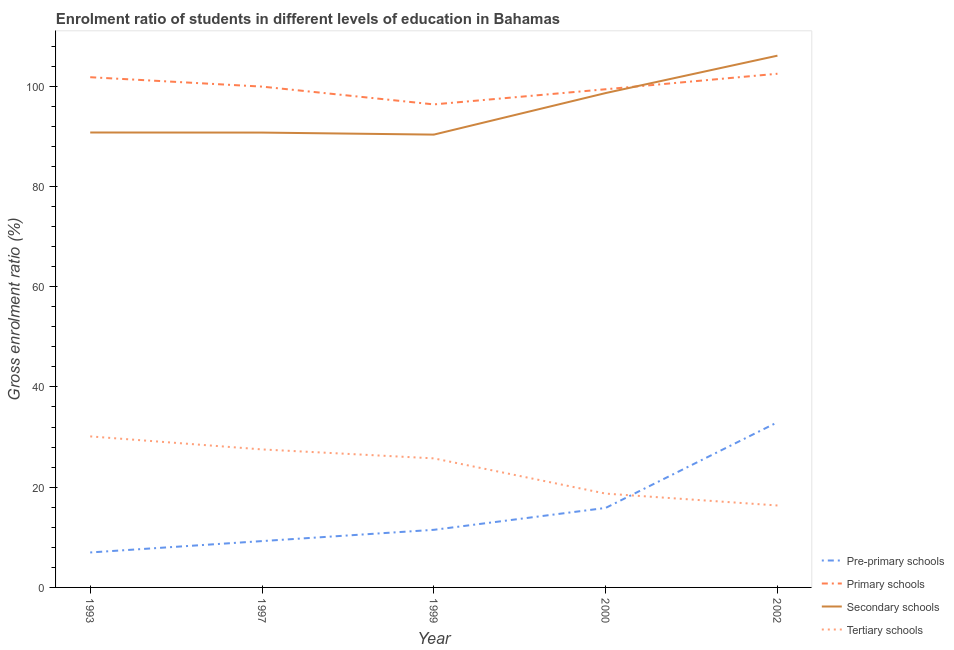How many different coloured lines are there?
Your answer should be compact. 4. Is the number of lines equal to the number of legend labels?
Offer a terse response. Yes. What is the gross enrolment ratio in secondary schools in 1999?
Your response must be concise. 90.34. Across all years, what is the maximum gross enrolment ratio in secondary schools?
Your answer should be compact. 106.09. Across all years, what is the minimum gross enrolment ratio in secondary schools?
Give a very brief answer. 90.34. In which year was the gross enrolment ratio in secondary schools minimum?
Give a very brief answer. 1999. What is the total gross enrolment ratio in secondary schools in the graph?
Offer a terse response. 476.59. What is the difference between the gross enrolment ratio in primary schools in 1993 and that in 1999?
Provide a short and direct response. 5.42. What is the difference between the gross enrolment ratio in secondary schools in 1993 and the gross enrolment ratio in tertiary schools in 2000?
Your response must be concise. 72.05. What is the average gross enrolment ratio in secondary schools per year?
Offer a very short reply. 95.32. In the year 1993, what is the difference between the gross enrolment ratio in primary schools and gross enrolment ratio in pre-primary schools?
Keep it short and to the point. 94.82. In how many years, is the gross enrolment ratio in tertiary schools greater than 76 %?
Your answer should be very brief. 0. What is the ratio of the gross enrolment ratio in primary schools in 2000 to that in 2002?
Provide a short and direct response. 0.97. Is the gross enrolment ratio in secondary schools in 1993 less than that in 1997?
Give a very brief answer. No. Is the difference between the gross enrolment ratio in primary schools in 1997 and 1999 greater than the difference between the gross enrolment ratio in secondary schools in 1997 and 1999?
Offer a very short reply. Yes. What is the difference between the highest and the second highest gross enrolment ratio in pre-primary schools?
Offer a terse response. 17.1. What is the difference between the highest and the lowest gross enrolment ratio in tertiary schools?
Provide a short and direct response. 13.78. Is the sum of the gross enrolment ratio in primary schools in 1997 and 2002 greater than the maximum gross enrolment ratio in secondary schools across all years?
Offer a terse response. Yes. Is it the case that in every year, the sum of the gross enrolment ratio in pre-primary schools and gross enrolment ratio in tertiary schools is greater than the sum of gross enrolment ratio in primary schools and gross enrolment ratio in secondary schools?
Give a very brief answer. No. Is it the case that in every year, the sum of the gross enrolment ratio in pre-primary schools and gross enrolment ratio in primary schools is greater than the gross enrolment ratio in secondary schools?
Provide a succinct answer. Yes. Is the gross enrolment ratio in primary schools strictly greater than the gross enrolment ratio in pre-primary schools over the years?
Your answer should be compact. Yes. Is the gross enrolment ratio in pre-primary schools strictly less than the gross enrolment ratio in tertiary schools over the years?
Your answer should be very brief. No. What is the difference between two consecutive major ticks on the Y-axis?
Provide a succinct answer. 20. Does the graph contain grids?
Offer a very short reply. No. Where does the legend appear in the graph?
Ensure brevity in your answer.  Bottom right. How many legend labels are there?
Offer a terse response. 4. How are the legend labels stacked?
Ensure brevity in your answer.  Vertical. What is the title of the graph?
Your answer should be very brief. Enrolment ratio of students in different levels of education in Bahamas. Does "Forest" appear as one of the legend labels in the graph?
Your answer should be very brief. No. What is the label or title of the X-axis?
Keep it short and to the point. Year. What is the Gross enrolment ratio (%) in Pre-primary schools in 1993?
Offer a very short reply. 6.98. What is the Gross enrolment ratio (%) of Primary schools in 1993?
Your response must be concise. 101.8. What is the Gross enrolment ratio (%) in Secondary schools in 1993?
Your answer should be compact. 90.76. What is the Gross enrolment ratio (%) in Tertiary schools in 1993?
Provide a short and direct response. 30.13. What is the Gross enrolment ratio (%) of Pre-primary schools in 1997?
Offer a terse response. 9.25. What is the Gross enrolment ratio (%) of Primary schools in 1997?
Your response must be concise. 99.92. What is the Gross enrolment ratio (%) in Secondary schools in 1997?
Keep it short and to the point. 90.75. What is the Gross enrolment ratio (%) of Tertiary schools in 1997?
Offer a very short reply. 27.53. What is the Gross enrolment ratio (%) in Pre-primary schools in 1999?
Your answer should be very brief. 11.49. What is the Gross enrolment ratio (%) of Primary schools in 1999?
Provide a succinct answer. 96.37. What is the Gross enrolment ratio (%) of Secondary schools in 1999?
Offer a very short reply. 90.34. What is the Gross enrolment ratio (%) in Tertiary schools in 1999?
Make the answer very short. 25.75. What is the Gross enrolment ratio (%) in Pre-primary schools in 2000?
Your answer should be compact. 15.86. What is the Gross enrolment ratio (%) of Primary schools in 2000?
Give a very brief answer. 99.39. What is the Gross enrolment ratio (%) of Secondary schools in 2000?
Provide a succinct answer. 98.63. What is the Gross enrolment ratio (%) of Tertiary schools in 2000?
Provide a short and direct response. 18.72. What is the Gross enrolment ratio (%) of Pre-primary schools in 2002?
Offer a terse response. 32.96. What is the Gross enrolment ratio (%) in Primary schools in 2002?
Your answer should be compact. 102.49. What is the Gross enrolment ratio (%) in Secondary schools in 2002?
Provide a short and direct response. 106.09. What is the Gross enrolment ratio (%) of Tertiary schools in 2002?
Provide a succinct answer. 16.35. Across all years, what is the maximum Gross enrolment ratio (%) of Pre-primary schools?
Your answer should be compact. 32.96. Across all years, what is the maximum Gross enrolment ratio (%) of Primary schools?
Provide a short and direct response. 102.49. Across all years, what is the maximum Gross enrolment ratio (%) in Secondary schools?
Offer a very short reply. 106.09. Across all years, what is the maximum Gross enrolment ratio (%) of Tertiary schools?
Your response must be concise. 30.13. Across all years, what is the minimum Gross enrolment ratio (%) of Pre-primary schools?
Your answer should be very brief. 6.98. Across all years, what is the minimum Gross enrolment ratio (%) in Primary schools?
Give a very brief answer. 96.37. Across all years, what is the minimum Gross enrolment ratio (%) of Secondary schools?
Your answer should be compact. 90.34. Across all years, what is the minimum Gross enrolment ratio (%) in Tertiary schools?
Ensure brevity in your answer.  16.35. What is the total Gross enrolment ratio (%) of Pre-primary schools in the graph?
Offer a terse response. 76.53. What is the total Gross enrolment ratio (%) of Primary schools in the graph?
Give a very brief answer. 499.97. What is the total Gross enrolment ratio (%) of Secondary schools in the graph?
Your answer should be very brief. 476.59. What is the total Gross enrolment ratio (%) of Tertiary schools in the graph?
Provide a short and direct response. 118.49. What is the difference between the Gross enrolment ratio (%) in Pre-primary schools in 1993 and that in 1997?
Keep it short and to the point. -2.27. What is the difference between the Gross enrolment ratio (%) of Primary schools in 1993 and that in 1997?
Offer a very short reply. 1.88. What is the difference between the Gross enrolment ratio (%) of Secondary schools in 1993 and that in 1997?
Offer a terse response. 0.01. What is the difference between the Gross enrolment ratio (%) in Tertiary schools in 1993 and that in 1997?
Ensure brevity in your answer.  2.6. What is the difference between the Gross enrolment ratio (%) of Pre-primary schools in 1993 and that in 1999?
Your answer should be compact. -4.52. What is the difference between the Gross enrolment ratio (%) of Primary schools in 1993 and that in 1999?
Give a very brief answer. 5.42. What is the difference between the Gross enrolment ratio (%) of Secondary schools in 1993 and that in 1999?
Offer a terse response. 0.42. What is the difference between the Gross enrolment ratio (%) of Tertiary schools in 1993 and that in 1999?
Your response must be concise. 4.38. What is the difference between the Gross enrolment ratio (%) in Pre-primary schools in 1993 and that in 2000?
Ensure brevity in your answer.  -8.88. What is the difference between the Gross enrolment ratio (%) in Primary schools in 1993 and that in 2000?
Your answer should be compact. 2.4. What is the difference between the Gross enrolment ratio (%) of Secondary schools in 1993 and that in 2000?
Your answer should be very brief. -7.87. What is the difference between the Gross enrolment ratio (%) in Tertiary schools in 1993 and that in 2000?
Ensure brevity in your answer.  11.41. What is the difference between the Gross enrolment ratio (%) of Pre-primary schools in 1993 and that in 2002?
Provide a succinct answer. -25.98. What is the difference between the Gross enrolment ratio (%) of Primary schools in 1993 and that in 2002?
Your answer should be compact. -0.69. What is the difference between the Gross enrolment ratio (%) in Secondary schools in 1993 and that in 2002?
Your response must be concise. -15.33. What is the difference between the Gross enrolment ratio (%) in Tertiary schools in 1993 and that in 2002?
Your answer should be very brief. 13.78. What is the difference between the Gross enrolment ratio (%) of Pre-primary schools in 1997 and that in 1999?
Ensure brevity in your answer.  -2.25. What is the difference between the Gross enrolment ratio (%) in Primary schools in 1997 and that in 1999?
Give a very brief answer. 3.55. What is the difference between the Gross enrolment ratio (%) of Secondary schools in 1997 and that in 1999?
Your answer should be very brief. 0.41. What is the difference between the Gross enrolment ratio (%) of Tertiary schools in 1997 and that in 1999?
Your response must be concise. 1.79. What is the difference between the Gross enrolment ratio (%) of Pre-primary schools in 1997 and that in 2000?
Make the answer very short. -6.61. What is the difference between the Gross enrolment ratio (%) in Primary schools in 1997 and that in 2000?
Offer a very short reply. 0.53. What is the difference between the Gross enrolment ratio (%) in Secondary schools in 1997 and that in 2000?
Offer a very short reply. -7.88. What is the difference between the Gross enrolment ratio (%) in Tertiary schools in 1997 and that in 2000?
Ensure brevity in your answer.  8.82. What is the difference between the Gross enrolment ratio (%) of Pre-primary schools in 1997 and that in 2002?
Make the answer very short. -23.71. What is the difference between the Gross enrolment ratio (%) of Primary schools in 1997 and that in 2002?
Provide a succinct answer. -2.57. What is the difference between the Gross enrolment ratio (%) in Secondary schools in 1997 and that in 2002?
Provide a succinct answer. -15.34. What is the difference between the Gross enrolment ratio (%) in Tertiary schools in 1997 and that in 2002?
Provide a short and direct response. 11.18. What is the difference between the Gross enrolment ratio (%) in Pre-primary schools in 1999 and that in 2000?
Your answer should be very brief. -4.37. What is the difference between the Gross enrolment ratio (%) in Primary schools in 1999 and that in 2000?
Your response must be concise. -3.02. What is the difference between the Gross enrolment ratio (%) of Secondary schools in 1999 and that in 2000?
Provide a short and direct response. -8.29. What is the difference between the Gross enrolment ratio (%) of Tertiary schools in 1999 and that in 2000?
Make the answer very short. 7.03. What is the difference between the Gross enrolment ratio (%) of Pre-primary schools in 1999 and that in 2002?
Keep it short and to the point. -21.46. What is the difference between the Gross enrolment ratio (%) of Primary schools in 1999 and that in 2002?
Ensure brevity in your answer.  -6.12. What is the difference between the Gross enrolment ratio (%) of Secondary schools in 1999 and that in 2002?
Offer a terse response. -15.75. What is the difference between the Gross enrolment ratio (%) in Tertiary schools in 1999 and that in 2002?
Provide a succinct answer. 9.4. What is the difference between the Gross enrolment ratio (%) in Pre-primary schools in 2000 and that in 2002?
Provide a short and direct response. -17.1. What is the difference between the Gross enrolment ratio (%) in Primary schools in 2000 and that in 2002?
Make the answer very short. -3.09. What is the difference between the Gross enrolment ratio (%) in Secondary schools in 2000 and that in 2002?
Make the answer very short. -7.46. What is the difference between the Gross enrolment ratio (%) in Tertiary schools in 2000 and that in 2002?
Your answer should be compact. 2.37. What is the difference between the Gross enrolment ratio (%) in Pre-primary schools in 1993 and the Gross enrolment ratio (%) in Primary schools in 1997?
Your answer should be compact. -92.94. What is the difference between the Gross enrolment ratio (%) in Pre-primary schools in 1993 and the Gross enrolment ratio (%) in Secondary schools in 1997?
Offer a very short reply. -83.77. What is the difference between the Gross enrolment ratio (%) of Pre-primary schools in 1993 and the Gross enrolment ratio (%) of Tertiary schools in 1997?
Provide a succinct answer. -20.56. What is the difference between the Gross enrolment ratio (%) of Primary schools in 1993 and the Gross enrolment ratio (%) of Secondary schools in 1997?
Your response must be concise. 11.05. What is the difference between the Gross enrolment ratio (%) of Primary schools in 1993 and the Gross enrolment ratio (%) of Tertiary schools in 1997?
Ensure brevity in your answer.  74.26. What is the difference between the Gross enrolment ratio (%) in Secondary schools in 1993 and the Gross enrolment ratio (%) in Tertiary schools in 1997?
Offer a terse response. 63.23. What is the difference between the Gross enrolment ratio (%) of Pre-primary schools in 1993 and the Gross enrolment ratio (%) of Primary schools in 1999?
Your answer should be very brief. -89.4. What is the difference between the Gross enrolment ratio (%) of Pre-primary schools in 1993 and the Gross enrolment ratio (%) of Secondary schools in 1999?
Provide a short and direct response. -83.37. What is the difference between the Gross enrolment ratio (%) of Pre-primary schools in 1993 and the Gross enrolment ratio (%) of Tertiary schools in 1999?
Your answer should be compact. -18.77. What is the difference between the Gross enrolment ratio (%) of Primary schools in 1993 and the Gross enrolment ratio (%) of Secondary schools in 1999?
Offer a very short reply. 11.45. What is the difference between the Gross enrolment ratio (%) of Primary schools in 1993 and the Gross enrolment ratio (%) of Tertiary schools in 1999?
Keep it short and to the point. 76.05. What is the difference between the Gross enrolment ratio (%) of Secondary schools in 1993 and the Gross enrolment ratio (%) of Tertiary schools in 1999?
Offer a terse response. 65.02. What is the difference between the Gross enrolment ratio (%) of Pre-primary schools in 1993 and the Gross enrolment ratio (%) of Primary schools in 2000?
Offer a very short reply. -92.42. What is the difference between the Gross enrolment ratio (%) of Pre-primary schools in 1993 and the Gross enrolment ratio (%) of Secondary schools in 2000?
Provide a short and direct response. -91.66. What is the difference between the Gross enrolment ratio (%) of Pre-primary schools in 1993 and the Gross enrolment ratio (%) of Tertiary schools in 2000?
Offer a very short reply. -11.74. What is the difference between the Gross enrolment ratio (%) of Primary schools in 1993 and the Gross enrolment ratio (%) of Secondary schools in 2000?
Provide a short and direct response. 3.16. What is the difference between the Gross enrolment ratio (%) of Primary schools in 1993 and the Gross enrolment ratio (%) of Tertiary schools in 2000?
Provide a short and direct response. 83.08. What is the difference between the Gross enrolment ratio (%) in Secondary schools in 1993 and the Gross enrolment ratio (%) in Tertiary schools in 2000?
Give a very brief answer. 72.05. What is the difference between the Gross enrolment ratio (%) of Pre-primary schools in 1993 and the Gross enrolment ratio (%) of Primary schools in 2002?
Your answer should be very brief. -95.51. What is the difference between the Gross enrolment ratio (%) of Pre-primary schools in 1993 and the Gross enrolment ratio (%) of Secondary schools in 2002?
Keep it short and to the point. -99.12. What is the difference between the Gross enrolment ratio (%) of Pre-primary schools in 1993 and the Gross enrolment ratio (%) of Tertiary schools in 2002?
Keep it short and to the point. -9.38. What is the difference between the Gross enrolment ratio (%) in Primary schools in 1993 and the Gross enrolment ratio (%) in Secondary schools in 2002?
Your answer should be compact. -4.3. What is the difference between the Gross enrolment ratio (%) of Primary schools in 1993 and the Gross enrolment ratio (%) of Tertiary schools in 2002?
Offer a terse response. 85.44. What is the difference between the Gross enrolment ratio (%) of Secondary schools in 1993 and the Gross enrolment ratio (%) of Tertiary schools in 2002?
Offer a very short reply. 74.41. What is the difference between the Gross enrolment ratio (%) in Pre-primary schools in 1997 and the Gross enrolment ratio (%) in Primary schools in 1999?
Provide a short and direct response. -87.13. What is the difference between the Gross enrolment ratio (%) in Pre-primary schools in 1997 and the Gross enrolment ratio (%) in Secondary schools in 1999?
Offer a terse response. -81.1. What is the difference between the Gross enrolment ratio (%) of Pre-primary schools in 1997 and the Gross enrolment ratio (%) of Tertiary schools in 1999?
Offer a terse response. -16.5. What is the difference between the Gross enrolment ratio (%) of Primary schools in 1997 and the Gross enrolment ratio (%) of Secondary schools in 1999?
Keep it short and to the point. 9.57. What is the difference between the Gross enrolment ratio (%) of Primary schools in 1997 and the Gross enrolment ratio (%) of Tertiary schools in 1999?
Your answer should be very brief. 74.17. What is the difference between the Gross enrolment ratio (%) of Secondary schools in 1997 and the Gross enrolment ratio (%) of Tertiary schools in 1999?
Offer a terse response. 65. What is the difference between the Gross enrolment ratio (%) of Pre-primary schools in 1997 and the Gross enrolment ratio (%) of Primary schools in 2000?
Keep it short and to the point. -90.15. What is the difference between the Gross enrolment ratio (%) in Pre-primary schools in 1997 and the Gross enrolment ratio (%) in Secondary schools in 2000?
Keep it short and to the point. -89.39. What is the difference between the Gross enrolment ratio (%) of Pre-primary schools in 1997 and the Gross enrolment ratio (%) of Tertiary schools in 2000?
Your response must be concise. -9.47. What is the difference between the Gross enrolment ratio (%) of Primary schools in 1997 and the Gross enrolment ratio (%) of Secondary schools in 2000?
Offer a very short reply. 1.29. What is the difference between the Gross enrolment ratio (%) of Primary schools in 1997 and the Gross enrolment ratio (%) of Tertiary schools in 2000?
Give a very brief answer. 81.2. What is the difference between the Gross enrolment ratio (%) in Secondary schools in 1997 and the Gross enrolment ratio (%) in Tertiary schools in 2000?
Keep it short and to the point. 72.03. What is the difference between the Gross enrolment ratio (%) of Pre-primary schools in 1997 and the Gross enrolment ratio (%) of Primary schools in 2002?
Provide a short and direct response. -93.24. What is the difference between the Gross enrolment ratio (%) of Pre-primary schools in 1997 and the Gross enrolment ratio (%) of Secondary schools in 2002?
Make the answer very short. -96.85. What is the difference between the Gross enrolment ratio (%) of Pre-primary schools in 1997 and the Gross enrolment ratio (%) of Tertiary schools in 2002?
Provide a short and direct response. -7.11. What is the difference between the Gross enrolment ratio (%) in Primary schools in 1997 and the Gross enrolment ratio (%) in Secondary schools in 2002?
Offer a terse response. -6.18. What is the difference between the Gross enrolment ratio (%) of Primary schools in 1997 and the Gross enrolment ratio (%) of Tertiary schools in 2002?
Offer a terse response. 83.57. What is the difference between the Gross enrolment ratio (%) in Secondary schools in 1997 and the Gross enrolment ratio (%) in Tertiary schools in 2002?
Your response must be concise. 74.4. What is the difference between the Gross enrolment ratio (%) of Pre-primary schools in 1999 and the Gross enrolment ratio (%) of Primary schools in 2000?
Your response must be concise. -87.9. What is the difference between the Gross enrolment ratio (%) in Pre-primary schools in 1999 and the Gross enrolment ratio (%) in Secondary schools in 2000?
Your response must be concise. -87.14. What is the difference between the Gross enrolment ratio (%) in Pre-primary schools in 1999 and the Gross enrolment ratio (%) in Tertiary schools in 2000?
Offer a very short reply. -7.22. What is the difference between the Gross enrolment ratio (%) of Primary schools in 1999 and the Gross enrolment ratio (%) of Secondary schools in 2000?
Provide a succinct answer. -2.26. What is the difference between the Gross enrolment ratio (%) of Primary schools in 1999 and the Gross enrolment ratio (%) of Tertiary schools in 2000?
Give a very brief answer. 77.65. What is the difference between the Gross enrolment ratio (%) of Secondary schools in 1999 and the Gross enrolment ratio (%) of Tertiary schools in 2000?
Provide a short and direct response. 71.63. What is the difference between the Gross enrolment ratio (%) of Pre-primary schools in 1999 and the Gross enrolment ratio (%) of Primary schools in 2002?
Make the answer very short. -90.99. What is the difference between the Gross enrolment ratio (%) in Pre-primary schools in 1999 and the Gross enrolment ratio (%) in Secondary schools in 2002?
Ensure brevity in your answer.  -94.6. What is the difference between the Gross enrolment ratio (%) in Pre-primary schools in 1999 and the Gross enrolment ratio (%) in Tertiary schools in 2002?
Offer a terse response. -4.86. What is the difference between the Gross enrolment ratio (%) in Primary schools in 1999 and the Gross enrolment ratio (%) in Secondary schools in 2002?
Give a very brief answer. -9.72. What is the difference between the Gross enrolment ratio (%) of Primary schools in 1999 and the Gross enrolment ratio (%) of Tertiary schools in 2002?
Offer a terse response. 80.02. What is the difference between the Gross enrolment ratio (%) of Secondary schools in 1999 and the Gross enrolment ratio (%) of Tertiary schools in 2002?
Give a very brief answer. 73.99. What is the difference between the Gross enrolment ratio (%) of Pre-primary schools in 2000 and the Gross enrolment ratio (%) of Primary schools in 2002?
Ensure brevity in your answer.  -86.63. What is the difference between the Gross enrolment ratio (%) of Pre-primary schools in 2000 and the Gross enrolment ratio (%) of Secondary schools in 2002?
Give a very brief answer. -90.24. What is the difference between the Gross enrolment ratio (%) in Pre-primary schools in 2000 and the Gross enrolment ratio (%) in Tertiary schools in 2002?
Your answer should be very brief. -0.49. What is the difference between the Gross enrolment ratio (%) in Primary schools in 2000 and the Gross enrolment ratio (%) in Secondary schools in 2002?
Offer a terse response. -6.7. What is the difference between the Gross enrolment ratio (%) of Primary schools in 2000 and the Gross enrolment ratio (%) of Tertiary schools in 2002?
Provide a succinct answer. 83.04. What is the difference between the Gross enrolment ratio (%) in Secondary schools in 2000 and the Gross enrolment ratio (%) in Tertiary schools in 2002?
Ensure brevity in your answer.  82.28. What is the average Gross enrolment ratio (%) in Pre-primary schools per year?
Provide a succinct answer. 15.31. What is the average Gross enrolment ratio (%) of Primary schools per year?
Offer a very short reply. 99.99. What is the average Gross enrolment ratio (%) in Secondary schools per year?
Give a very brief answer. 95.32. What is the average Gross enrolment ratio (%) in Tertiary schools per year?
Your answer should be compact. 23.7. In the year 1993, what is the difference between the Gross enrolment ratio (%) of Pre-primary schools and Gross enrolment ratio (%) of Primary schools?
Provide a short and direct response. -94.82. In the year 1993, what is the difference between the Gross enrolment ratio (%) in Pre-primary schools and Gross enrolment ratio (%) in Secondary schools?
Make the answer very short. -83.79. In the year 1993, what is the difference between the Gross enrolment ratio (%) of Pre-primary schools and Gross enrolment ratio (%) of Tertiary schools?
Offer a terse response. -23.16. In the year 1993, what is the difference between the Gross enrolment ratio (%) of Primary schools and Gross enrolment ratio (%) of Secondary schools?
Your response must be concise. 11.03. In the year 1993, what is the difference between the Gross enrolment ratio (%) in Primary schools and Gross enrolment ratio (%) in Tertiary schools?
Give a very brief answer. 71.66. In the year 1993, what is the difference between the Gross enrolment ratio (%) of Secondary schools and Gross enrolment ratio (%) of Tertiary schools?
Provide a succinct answer. 60.63. In the year 1997, what is the difference between the Gross enrolment ratio (%) of Pre-primary schools and Gross enrolment ratio (%) of Primary schools?
Offer a very short reply. -90.67. In the year 1997, what is the difference between the Gross enrolment ratio (%) in Pre-primary schools and Gross enrolment ratio (%) in Secondary schools?
Give a very brief answer. -81.5. In the year 1997, what is the difference between the Gross enrolment ratio (%) of Pre-primary schools and Gross enrolment ratio (%) of Tertiary schools?
Keep it short and to the point. -18.29. In the year 1997, what is the difference between the Gross enrolment ratio (%) in Primary schools and Gross enrolment ratio (%) in Secondary schools?
Offer a very short reply. 9.17. In the year 1997, what is the difference between the Gross enrolment ratio (%) of Primary schools and Gross enrolment ratio (%) of Tertiary schools?
Offer a very short reply. 72.38. In the year 1997, what is the difference between the Gross enrolment ratio (%) of Secondary schools and Gross enrolment ratio (%) of Tertiary schools?
Offer a terse response. 63.22. In the year 1999, what is the difference between the Gross enrolment ratio (%) of Pre-primary schools and Gross enrolment ratio (%) of Primary schools?
Your response must be concise. -84.88. In the year 1999, what is the difference between the Gross enrolment ratio (%) of Pre-primary schools and Gross enrolment ratio (%) of Secondary schools?
Give a very brief answer. -78.85. In the year 1999, what is the difference between the Gross enrolment ratio (%) of Pre-primary schools and Gross enrolment ratio (%) of Tertiary schools?
Offer a terse response. -14.26. In the year 1999, what is the difference between the Gross enrolment ratio (%) in Primary schools and Gross enrolment ratio (%) in Secondary schools?
Provide a short and direct response. 6.03. In the year 1999, what is the difference between the Gross enrolment ratio (%) in Primary schools and Gross enrolment ratio (%) in Tertiary schools?
Your response must be concise. 70.62. In the year 1999, what is the difference between the Gross enrolment ratio (%) of Secondary schools and Gross enrolment ratio (%) of Tertiary schools?
Make the answer very short. 64.6. In the year 2000, what is the difference between the Gross enrolment ratio (%) of Pre-primary schools and Gross enrolment ratio (%) of Primary schools?
Give a very brief answer. -83.53. In the year 2000, what is the difference between the Gross enrolment ratio (%) of Pre-primary schools and Gross enrolment ratio (%) of Secondary schools?
Keep it short and to the point. -82.77. In the year 2000, what is the difference between the Gross enrolment ratio (%) in Pre-primary schools and Gross enrolment ratio (%) in Tertiary schools?
Your response must be concise. -2.86. In the year 2000, what is the difference between the Gross enrolment ratio (%) in Primary schools and Gross enrolment ratio (%) in Secondary schools?
Provide a short and direct response. 0.76. In the year 2000, what is the difference between the Gross enrolment ratio (%) of Primary schools and Gross enrolment ratio (%) of Tertiary schools?
Your answer should be compact. 80.67. In the year 2000, what is the difference between the Gross enrolment ratio (%) of Secondary schools and Gross enrolment ratio (%) of Tertiary schools?
Your answer should be compact. 79.92. In the year 2002, what is the difference between the Gross enrolment ratio (%) of Pre-primary schools and Gross enrolment ratio (%) of Primary schools?
Provide a succinct answer. -69.53. In the year 2002, what is the difference between the Gross enrolment ratio (%) of Pre-primary schools and Gross enrolment ratio (%) of Secondary schools?
Make the answer very short. -73.14. In the year 2002, what is the difference between the Gross enrolment ratio (%) in Pre-primary schools and Gross enrolment ratio (%) in Tertiary schools?
Ensure brevity in your answer.  16.6. In the year 2002, what is the difference between the Gross enrolment ratio (%) in Primary schools and Gross enrolment ratio (%) in Secondary schools?
Ensure brevity in your answer.  -3.61. In the year 2002, what is the difference between the Gross enrolment ratio (%) of Primary schools and Gross enrolment ratio (%) of Tertiary schools?
Keep it short and to the point. 86.14. In the year 2002, what is the difference between the Gross enrolment ratio (%) in Secondary schools and Gross enrolment ratio (%) in Tertiary schools?
Make the answer very short. 89.74. What is the ratio of the Gross enrolment ratio (%) in Pre-primary schools in 1993 to that in 1997?
Make the answer very short. 0.75. What is the ratio of the Gross enrolment ratio (%) in Primary schools in 1993 to that in 1997?
Your answer should be compact. 1.02. What is the ratio of the Gross enrolment ratio (%) of Secondary schools in 1993 to that in 1997?
Make the answer very short. 1. What is the ratio of the Gross enrolment ratio (%) in Tertiary schools in 1993 to that in 1997?
Make the answer very short. 1.09. What is the ratio of the Gross enrolment ratio (%) of Pre-primary schools in 1993 to that in 1999?
Offer a very short reply. 0.61. What is the ratio of the Gross enrolment ratio (%) in Primary schools in 1993 to that in 1999?
Provide a succinct answer. 1.06. What is the ratio of the Gross enrolment ratio (%) of Secondary schools in 1993 to that in 1999?
Provide a short and direct response. 1. What is the ratio of the Gross enrolment ratio (%) in Tertiary schools in 1993 to that in 1999?
Provide a succinct answer. 1.17. What is the ratio of the Gross enrolment ratio (%) in Pre-primary schools in 1993 to that in 2000?
Your answer should be compact. 0.44. What is the ratio of the Gross enrolment ratio (%) in Primary schools in 1993 to that in 2000?
Give a very brief answer. 1.02. What is the ratio of the Gross enrolment ratio (%) in Secondary schools in 1993 to that in 2000?
Make the answer very short. 0.92. What is the ratio of the Gross enrolment ratio (%) of Tertiary schools in 1993 to that in 2000?
Offer a terse response. 1.61. What is the ratio of the Gross enrolment ratio (%) of Pre-primary schools in 1993 to that in 2002?
Your answer should be very brief. 0.21. What is the ratio of the Gross enrolment ratio (%) in Secondary schools in 1993 to that in 2002?
Your answer should be very brief. 0.86. What is the ratio of the Gross enrolment ratio (%) in Tertiary schools in 1993 to that in 2002?
Offer a terse response. 1.84. What is the ratio of the Gross enrolment ratio (%) of Pre-primary schools in 1997 to that in 1999?
Keep it short and to the point. 0.8. What is the ratio of the Gross enrolment ratio (%) of Primary schools in 1997 to that in 1999?
Ensure brevity in your answer.  1.04. What is the ratio of the Gross enrolment ratio (%) of Secondary schools in 1997 to that in 1999?
Make the answer very short. 1. What is the ratio of the Gross enrolment ratio (%) of Tertiary schools in 1997 to that in 1999?
Your answer should be very brief. 1.07. What is the ratio of the Gross enrolment ratio (%) of Pre-primary schools in 1997 to that in 2000?
Your answer should be compact. 0.58. What is the ratio of the Gross enrolment ratio (%) in Secondary schools in 1997 to that in 2000?
Your response must be concise. 0.92. What is the ratio of the Gross enrolment ratio (%) in Tertiary schools in 1997 to that in 2000?
Keep it short and to the point. 1.47. What is the ratio of the Gross enrolment ratio (%) of Pre-primary schools in 1997 to that in 2002?
Your answer should be compact. 0.28. What is the ratio of the Gross enrolment ratio (%) of Primary schools in 1997 to that in 2002?
Provide a succinct answer. 0.97. What is the ratio of the Gross enrolment ratio (%) in Secondary schools in 1997 to that in 2002?
Keep it short and to the point. 0.86. What is the ratio of the Gross enrolment ratio (%) in Tertiary schools in 1997 to that in 2002?
Your answer should be very brief. 1.68. What is the ratio of the Gross enrolment ratio (%) of Pre-primary schools in 1999 to that in 2000?
Provide a succinct answer. 0.72. What is the ratio of the Gross enrolment ratio (%) of Primary schools in 1999 to that in 2000?
Provide a short and direct response. 0.97. What is the ratio of the Gross enrolment ratio (%) of Secondary schools in 1999 to that in 2000?
Give a very brief answer. 0.92. What is the ratio of the Gross enrolment ratio (%) in Tertiary schools in 1999 to that in 2000?
Provide a short and direct response. 1.38. What is the ratio of the Gross enrolment ratio (%) in Pre-primary schools in 1999 to that in 2002?
Offer a very short reply. 0.35. What is the ratio of the Gross enrolment ratio (%) of Primary schools in 1999 to that in 2002?
Ensure brevity in your answer.  0.94. What is the ratio of the Gross enrolment ratio (%) of Secondary schools in 1999 to that in 2002?
Ensure brevity in your answer.  0.85. What is the ratio of the Gross enrolment ratio (%) of Tertiary schools in 1999 to that in 2002?
Offer a terse response. 1.57. What is the ratio of the Gross enrolment ratio (%) in Pre-primary schools in 2000 to that in 2002?
Give a very brief answer. 0.48. What is the ratio of the Gross enrolment ratio (%) of Primary schools in 2000 to that in 2002?
Provide a succinct answer. 0.97. What is the ratio of the Gross enrolment ratio (%) of Secondary schools in 2000 to that in 2002?
Your answer should be very brief. 0.93. What is the ratio of the Gross enrolment ratio (%) in Tertiary schools in 2000 to that in 2002?
Give a very brief answer. 1.14. What is the difference between the highest and the second highest Gross enrolment ratio (%) of Pre-primary schools?
Offer a terse response. 17.1. What is the difference between the highest and the second highest Gross enrolment ratio (%) of Primary schools?
Give a very brief answer. 0.69. What is the difference between the highest and the second highest Gross enrolment ratio (%) of Secondary schools?
Make the answer very short. 7.46. What is the difference between the highest and the second highest Gross enrolment ratio (%) in Tertiary schools?
Your response must be concise. 2.6. What is the difference between the highest and the lowest Gross enrolment ratio (%) in Pre-primary schools?
Your answer should be very brief. 25.98. What is the difference between the highest and the lowest Gross enrolment ratio (%) in Primary schools?
Provide a succinct answer. 6.12. What is the difference between the highest and the lowest Gross enrolment ratio (%) of Secondary schools?
Your answer should be compact. 15.75. What is the difference between the highest and the lowest Gross enrolment ratio (%) of Tertiary schools?
Offer a very short reply. 13.78. 